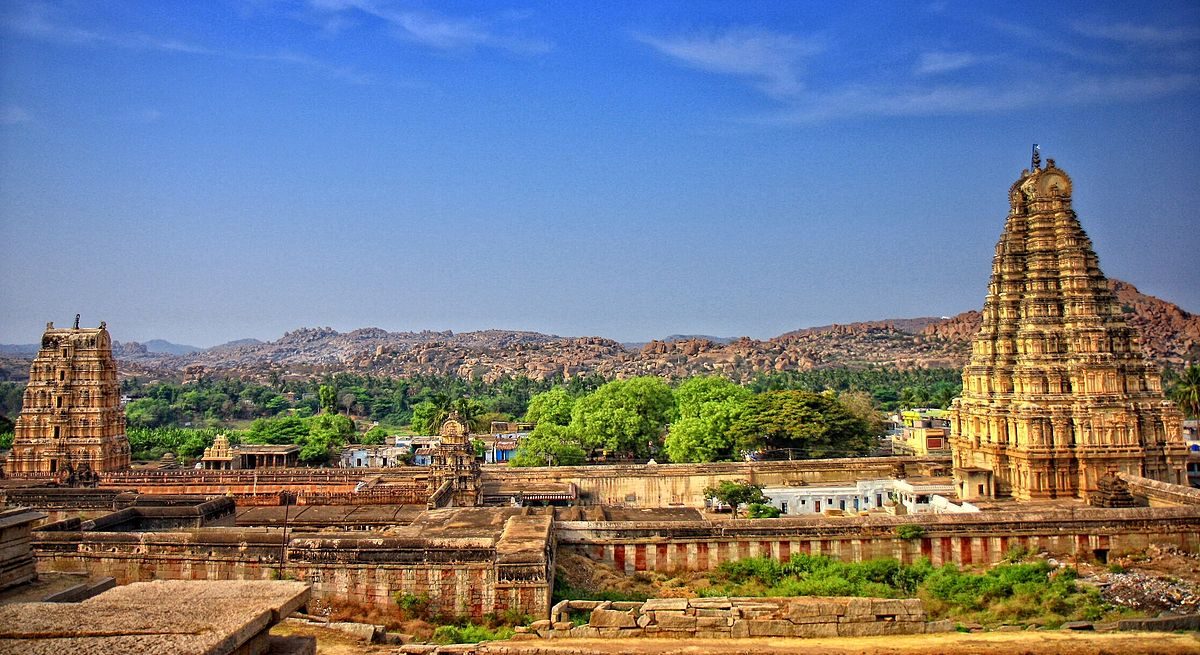Imagine an ancient ritual taking place at the temple complex; describe it in a detailed narrative. As the first light of dawn emerged, the temple priests, draped in white dhotis with sacred thread across their torsos, began their rituals. The air was crisp and filled with the faint scent of fresh flowers, sandalwood, and incense. They moved in a synchronized manner, carrying golden vessels filled with holy water from the Tungabhadra River, which flowed nearby. Chanting ancient Vedic hymns, they performed the abhishekam, bathing the main deity, Virupaksha, in water, milk, honey, and ghee, each symbolic of purification and divine nourishment.

The priests meticulously adorned the deity with vibrant flower garlands, precious jewels, and finely woven robes, transforming the idol into an exquisite manifestation of divinity. Devotees, some standing quietly with folded hands while others prostrated before the sanctum, observed in profound reverence. The rhythmic sound of the temple drums and the resonant timbre of conch shells permeated the atmosphere, enhancing the spiritual aura of the place.

As the sun climbed higher, the rituals converged into a grand aarti, where large oil lamps and camphor flames were waved in elaborate patterns before the deity, accompanied by clanging bells and the collective chants of the devotees. The flickering flame of the aarti, symbolizing the dispelling of darkness, cast a golden glow across the sacred space, merging the earthly with the divine realm. The ceremony culminated in priests distributing prasad, blessed food, among the devotees, leaving them in a state of spiritual bliss and contentment. 